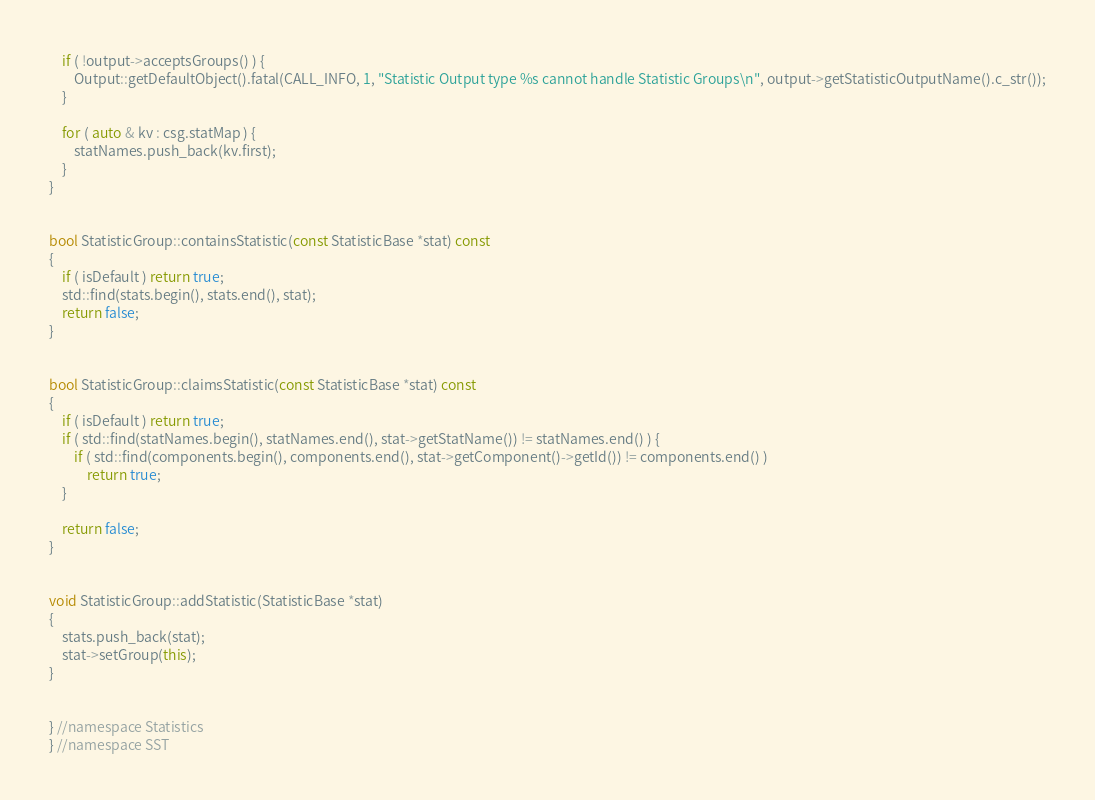<code> <loc_0><loc_0><loc_500><loc_500><_C++_>    if ( !output->acceptsGroups() ) {
        Output::getDefaultObject().fatal(CALL_INFO, 1, "Statistic Output type %s cannot handle Statistic Groups\n", output->getStatisticOutputName().c_str());
    }

    for ( auto & kv : csg.statMap ) {
        statNames.push_back(kv.first);
    }
}


bool StatisticGroup::containsStatistic(const StatisticBase *stat) const
{
    if ( isDefault ) return true;
    std::find(stats.begin(), stats.end(), stat);
    return false;
}


bool StatisticGroup::claimsStatistic(const StatisticBase *stat) const
{
    if ( isDefault ) return true;
    if ( std::find(statNames.begin(), statNames.end(), stat->getStatName()) != statNames.end() ) {
        if ( std::find(components.begin(), components.end(), stat->getComponent()->getId()) != components.end() )
            return true;
    }

    return false;
}


void StatisticGroup::addStatistic(StatisticBase *stat)
{
    stats.push_back(stat);
    stat->setGroup(this);
}


} //namespace Statistics
} //namespace SST

</code> 